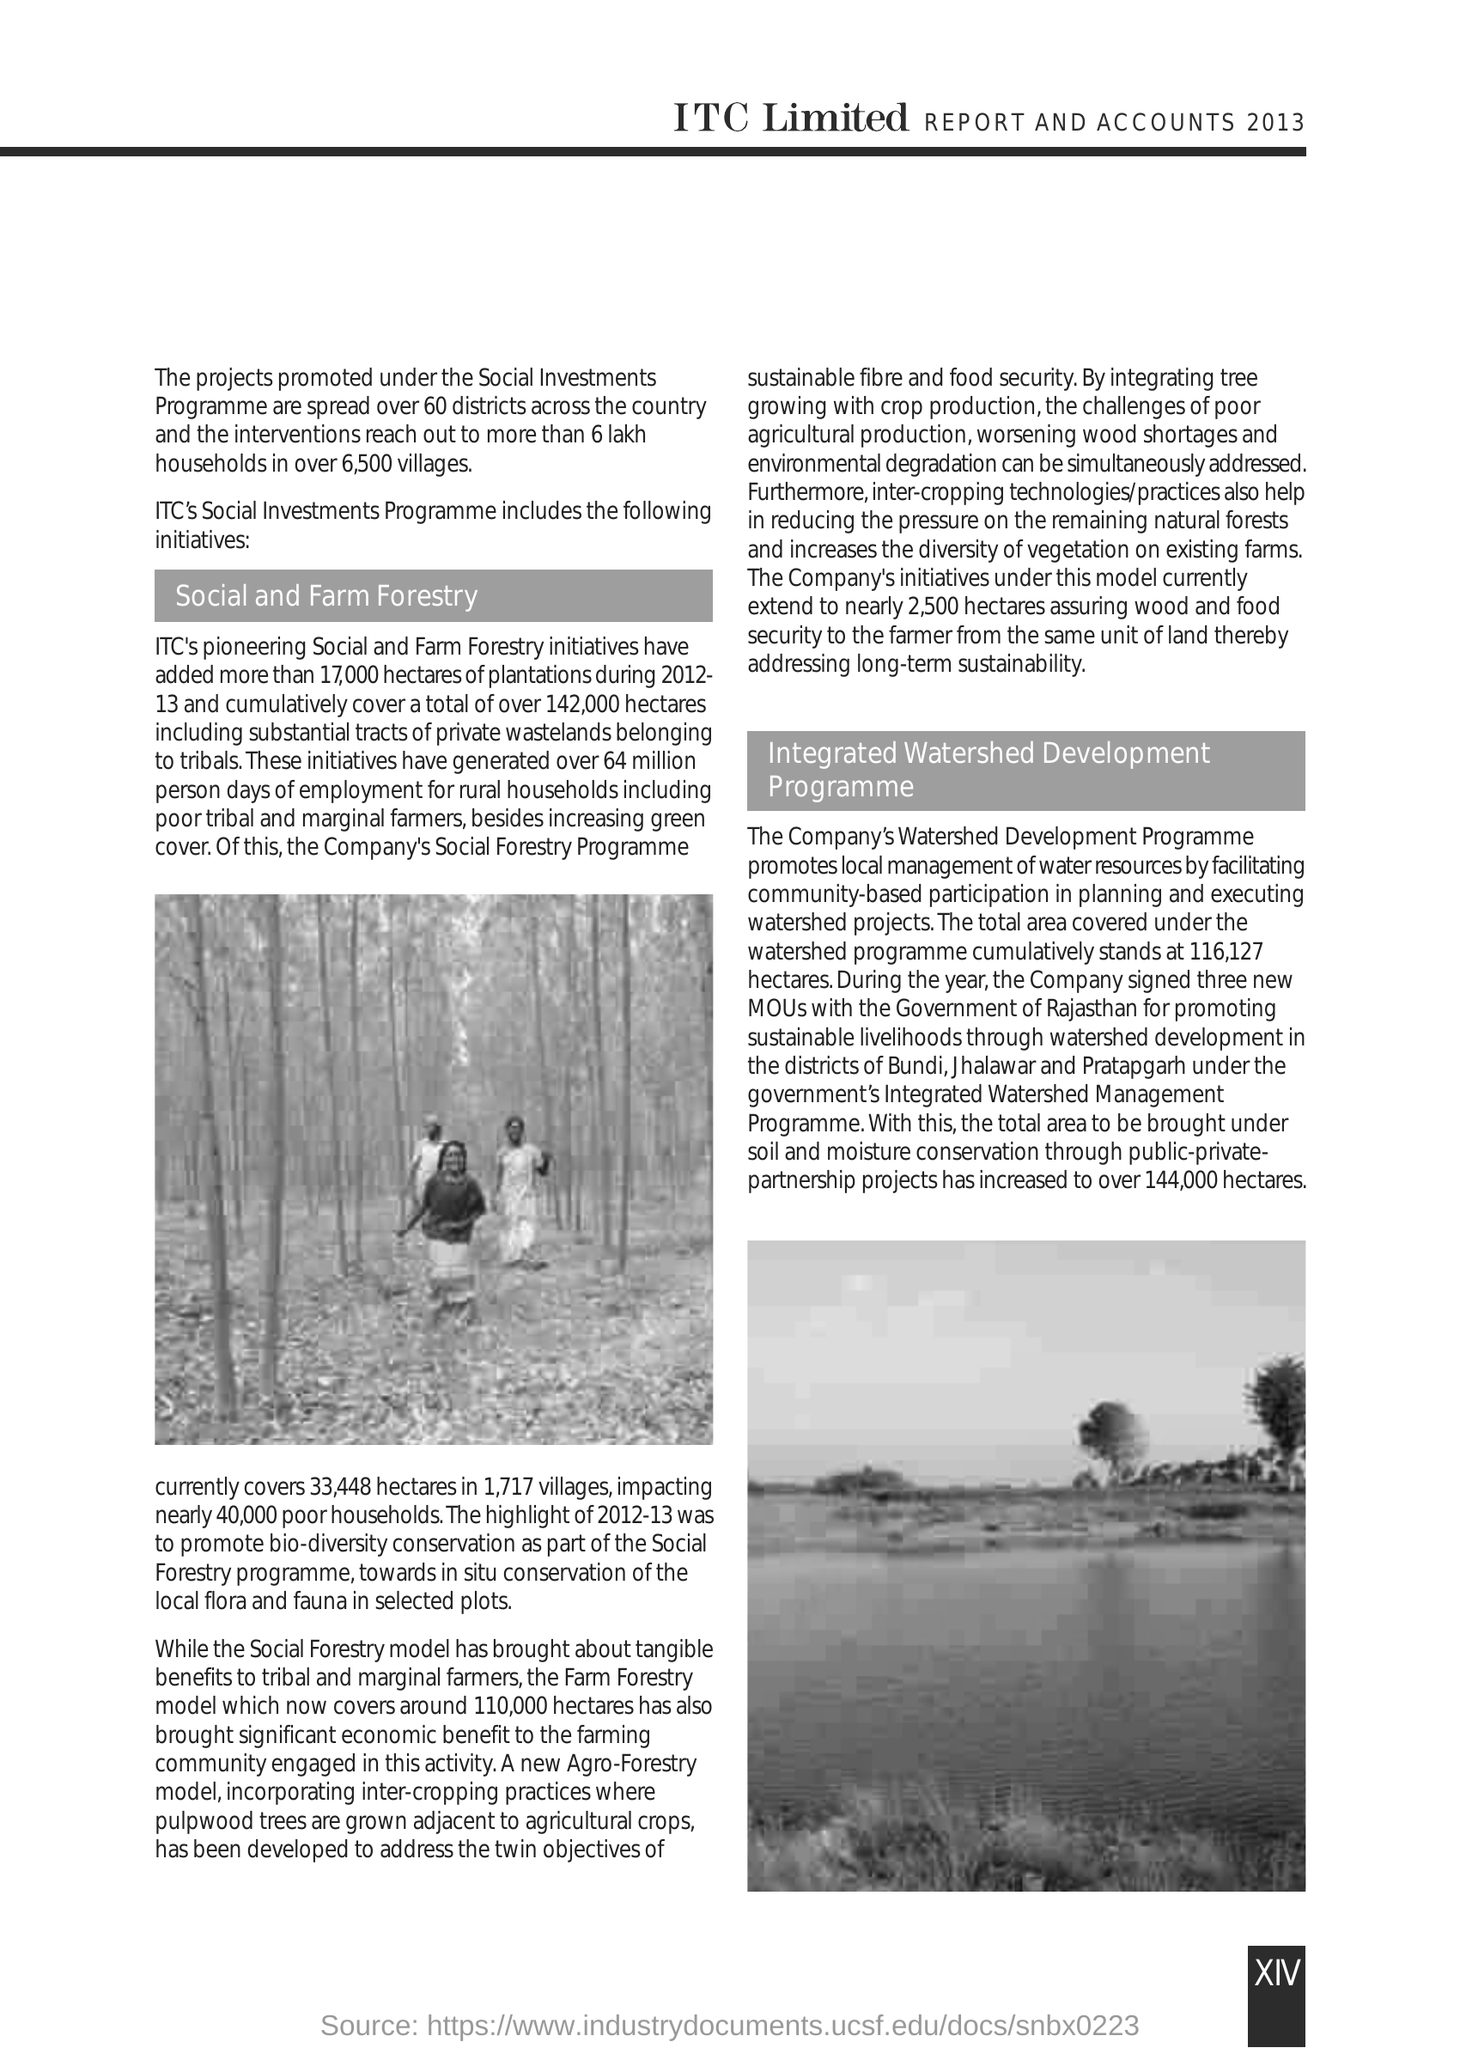"REPORTS AND ACCOUNTS" of which year is mentioned in the heading of the document?
Your response must be concise. 2013. "The projects promoted under the Social Investments Programme are spread over" how many districts across the country?
Your answer should be compact. 60 districts. Mention the first subheading given?
Make the answer very short. Social and Farm Forestry. Company's which programme impacts nearly 40,000 poor households?
Ensure brevity in your answer.  Social Forestry Programme. Company's which model addresses the twin objectives of sustainble fibre and food security?
Offer a very short reply. Agro-Forestry model. Mention the second subheading given?
Offer a terse response. Integrated Watershed Development Programme. Mention "the total area covered under the watershed Programme"?
Ensure brevity in your answer.  116,127 hectares. Company has signed three new MOUs with which Government?
Your response must be concise. Rajasthan. What is the page number given at the right bottom corner of the page?
Offer a terse response. XIV. 